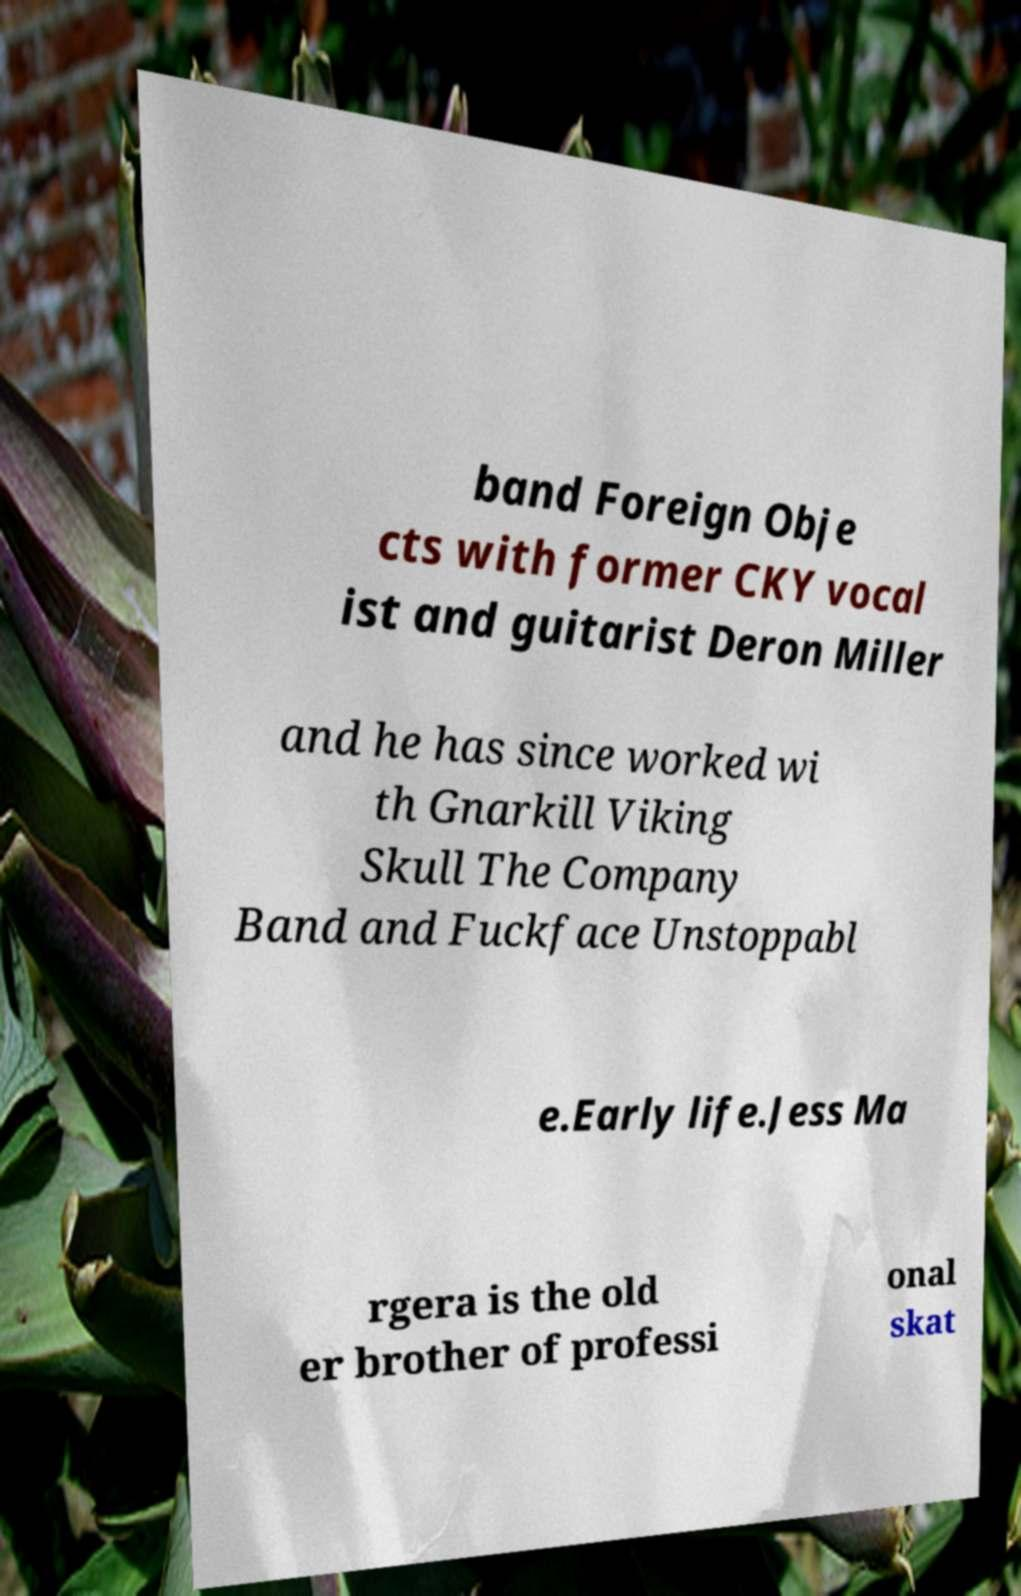Could you assist in decoding the text presented in this image and type it out clearly? band Foreign Obje cts with former CKY vocal ist and guitarist Deron Miller and he has since worked wi th Gnarkill Viking Skull The Company Band and Fuckface Unstoppabl e.Early life.Jess Ma rgera is the old er brother of professi onal skat 